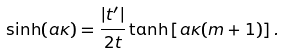Convert formula to latex. <formula><loc_0><loc_0><loc_500><loc_500>\sinh ( a \kappa ) = \frac { | t ^ { \prime } | } { 2 t } \tanh \left [ a \kappa ( m + 1 ) \right ] .</formula> 